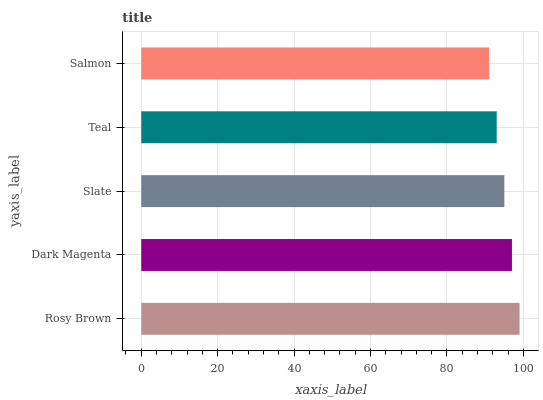Is Salmon the minimum?
Answer yes or no. Yes. Is Rosy Brown the maximum?
Answer yes or no. Yes. Is Dark Magenta the minimum?
Answer yes or no. No. Is Dark Magenta the maximum?
Answer yes or no. No. Is Rosy Brown greater than Dark Magenta?
Answer yes or no. Yes. Is Dark Magenta less than Rosy Brown?
Answer yes or no. Yes. Is Dark Magenta greater than Rosy Brown?
Answer yes or no. No. Is Rosy Brown less than Dark Magenta?
Answer yes or no. No. Is Slate the high median?
Answer yes or no. Yes. Is Slate the low median?
Answer yes or no. Yes. Is Teal the high median?
Answer yes or no. No. Is Salmon the low median?
Answer yes or no. No. 